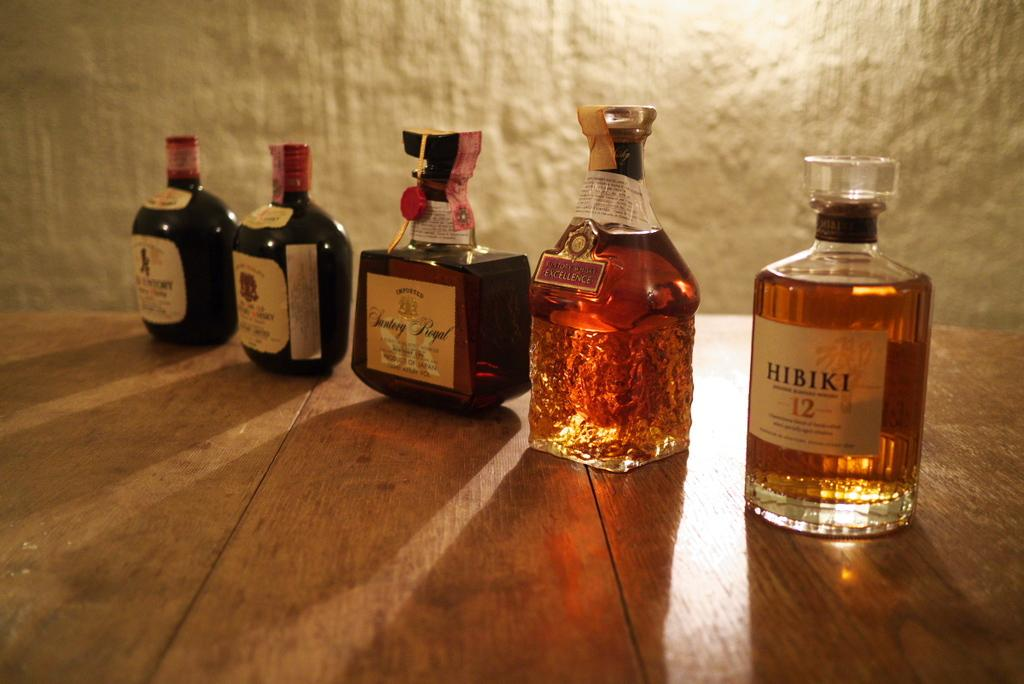<image>
Relay a brief, clear account of the picture shown. The glass bottle on the right contains Hibiki. 